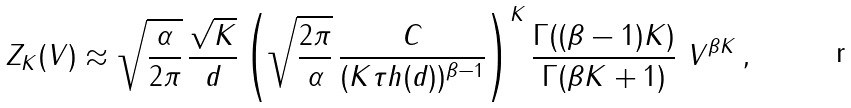Convert formula to latex. <formula><loc_0><loc_0><loc_500><loc_500>Z _ { K } ( V ) \approx \sqrt { \frac { \alpha } { 2 \pi } } \, \frac { \sqrt { K } } { d } \left ( \sqrt { \frac { 2 \pi } { \alpha } } \, \frac { C } { ( K \tau h ( d ) ) ^ { \beta - 1 } } \right ) ^ { K } \frac { \Gamma ( ( \beta - 1 ) K ) } { \Gamma ( \beta K + 1 ) } \ V ^ { \beta K } \, ,</formula> 